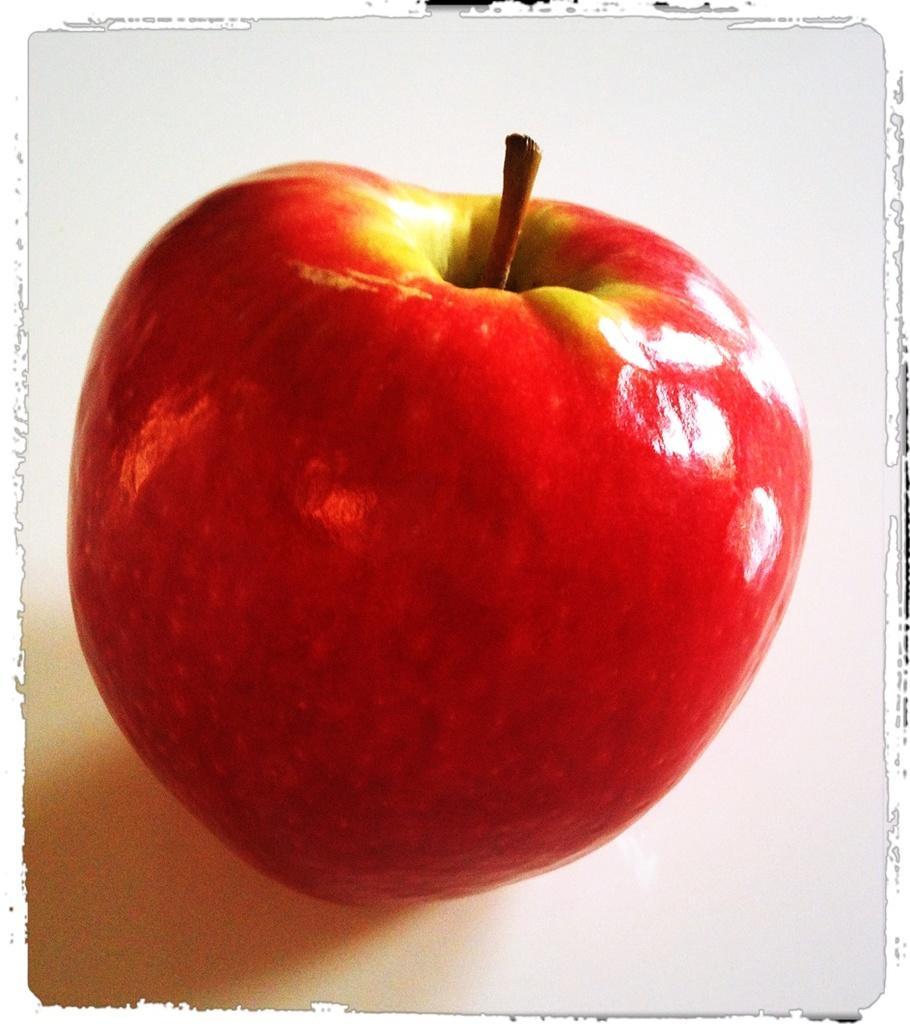Can you describe this image briefly? In this image I can see an apple on the floor. This image looks like a painting. 